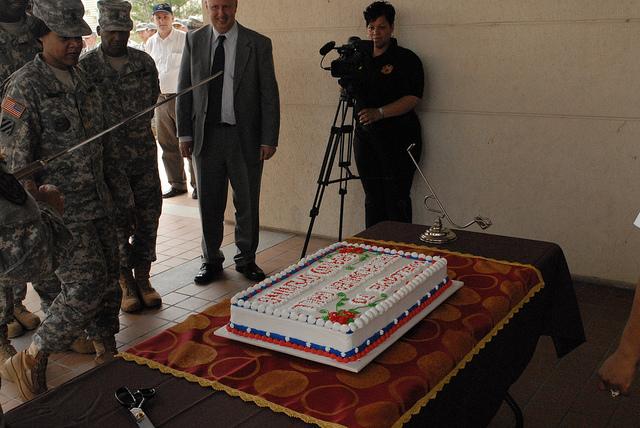Could that cake be sliced with a sword?
Be succinct. Yes. Is this a celebration?
Quick response, please. Yes. How many people are cutting the cake?
Give a very brief answer. 0. What type of special uniform is worn by the men and women?
Keep it brief. Military. 